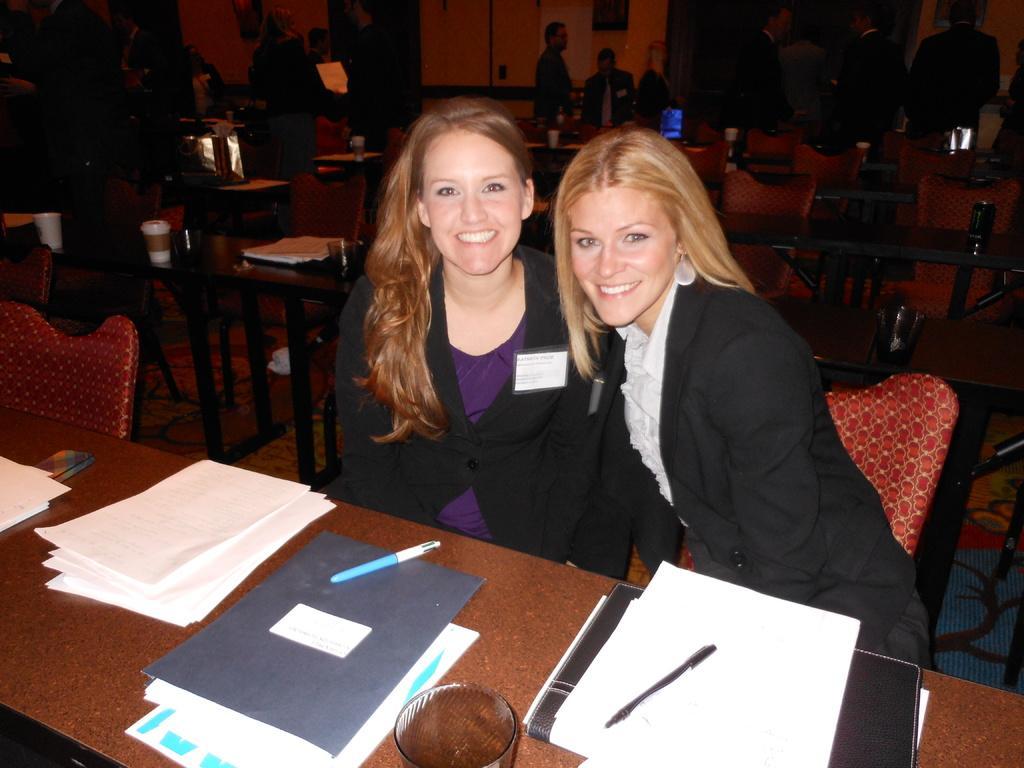In one or two sentences, can you explain what this image depicts? In this picture there are two women sitting on the chair and smiling. There have a table in front of them which has some paper, books and pens on it. 